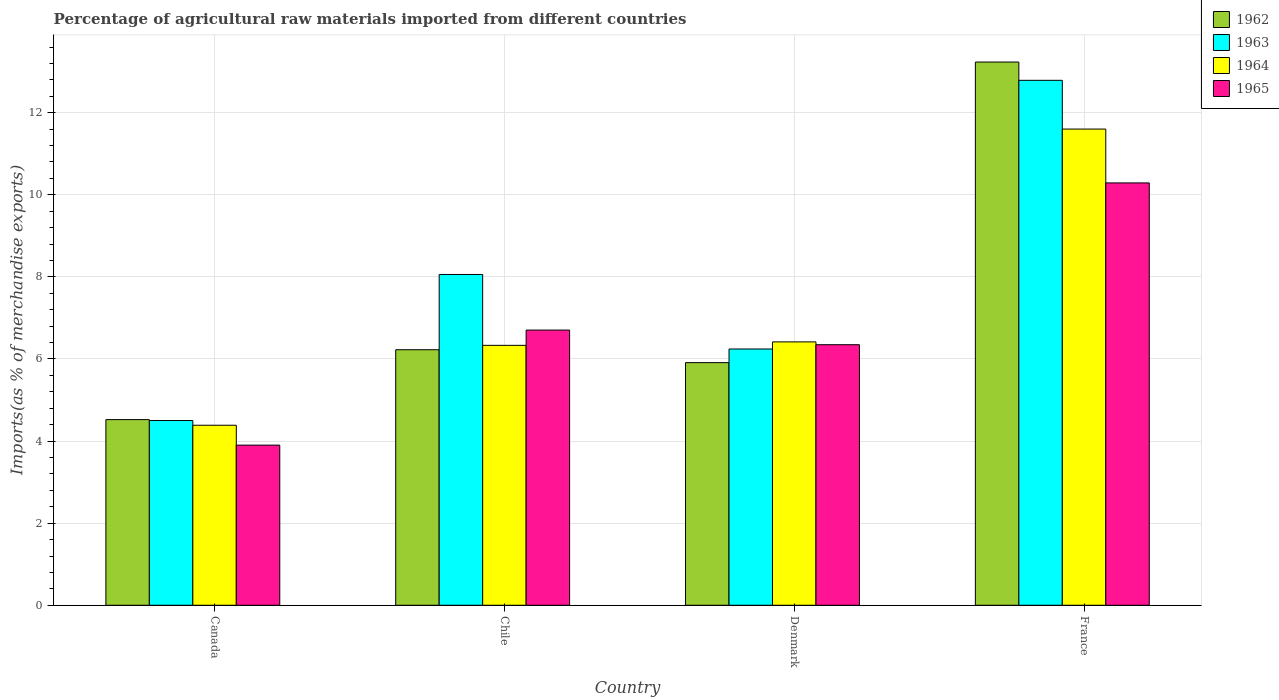How many different coloured bars are there?
Give a very brief answer. 4. How many groups of bars are there?
Your answer should be very brief. 4. Are the number of bars per tick equal to the number of legend labels?
Offer a very short reply. Yes. Are the number of bars on each tick of the X-axis equal?
Ensure brevity in your answer.  Yes. How many bars are there on the 4th tick from the right?
Offer a very short reply. 4. In how many cases, is the number of bars for a given country not equal to the number of legend labels?
Provide a short and direct response. 0. What is the percentage of imports to different countries in 1965 in Canada?
Your response must be concise. 3.9. Across all countries, what is the maximum percentage of imports to different countries in 1963?
Offer a very short reply. 12.79. Across all countries, what is the minimum percentage of imports to different countries in 1964?
Provide a succinct answer. 4.39. In which country was the percentage of imports to different countries in 1964 minimum?
Offer a terse response. Canada. What is the total percentage of imports to different countries in 1962 in the graph?
Keep it short and to the point. 29.9. What is the difference between the percentage of imports to different countries in 1965 in Canada and that in Chile?
Provide a succinct answer. -2.8. What is the difference between the percentage of imports to different countries in 1962 in Chile and the percentage of imports to different countries in 1963 in Denmark?
Provide a succinct answer. -0.02. What is the average percentage of imports to different countries in 1964 per country?
Your answer should be compact. 7.18. What is the difference between the percentage of imports to different countries of/in 1963 and percentage of imports to different countries of/in 1965 in Canada?
Provide a succinct answer. 0.6. What is the ratio of the percentage of imports to different countries in 1965 in Canada to that in Chile?
Give a very brief answer. 0.58. What is the difference between the highest and the second highest percentage of imports to different countries in 1962?
Keep it short and to the point. -7.32. What is the difference between the highest and the lowest percentage of imports to different countries in 1965?
Offer a very short reply. 6.39. Is the sum of the percentage of imports to different countries in 1964 in Denmark and France greater than the maximum percentage of imports to different countries in 1965 across all countries?
Make the answer very short. Yes. What does the 4th bar from the left in Canada represents?
Keep it short and to the point. 1965. What does the 1st bar from the right in Canada represents?
Offer a terse response. 1965. Are all the bars in the graph horizontal?
Your answer should be very brief. No. How many countries are there in the graph?
Provide a succinct answer. 4. Where does the legend appear in the graph?
Ensure brevity in your answer.  Top right. How many legend labels are there?
Provide a short and direct response. 4. What is the title of the graph?
Provide a succinct answer. Percentage of agricultural raw materials imported from different countries. What is the label or title of the Y-axis?
Offer a very short reply. Imports(as % of merchandise exports). What is the Imports(as % of merchandise exports) of 1962 in Canada?
Your response must be concise. 4.52. What is the Imports(as % of merchandise exports) of 1963 in Canada?
Provide a short and direct response. 4.5. What is the Imports(as % of merchandise exports) in 1964 in Canada?
Keep it short and to the point. 4.39. What is the Imports(as % of merchandise exports) in 1965 in Canada?
Keep it short and to the point. 3.9. What is the Imports(as % of merchandise exports) in 1962 in Chile?
Give a very brief answer. 6.23. What is the Imports(as % of merchandise exports) in 1963 in Chile?
Your answer should be compact. 8.06. What is the Imports(as % of merchandise exports) in 1964 in Chile?
Your answer should be very brief. 6.33. What is the Imports(as % of merchandise exports) of 1965 in Chile?
Provide a succinct answer. 6.7. What is the Imports(as % of merchandise exports) in 1962 in Denmark?
Provide a succinct answer. 5.91. What is the Imports(as % of merchandise exports) in 1963 in Denmark?
Provide a succinct answer. 6.24. What is the Imports(as % of merchandise exports) of 1964 in Denmark?
Offer a terse response. 6.42. What is the Imports(as % of merchandise exports) in 1965 in Denmark?
Ensure brevity in your answer.  6.35. What is the Imports(as % of merchandise exports) of 1962 in France?
Provide a succinct answer. 13.24. What is the Imports(as % of merchandise exports) of 1963 in France?
Offer a very short reply. 12.79. What is the Imports(as % of merchandise exports) in 1964 in France?
Keep it short and to the point. 11.6. What is the Imports(as % of merchandise exports) of 1965 in France?
Provide a succinct answer. 10.29. Across all countries, what is the maximum Imports(as % of merchandise exports) in 1962?
Offer a terse response. 13.24. Across all countries, what is the maximum Imports(as % of merchandise exports) of 1963?
Give a very brief answer. 12.79. Across all countries, what is the maximum Imports(as % of merchandise exports) in 1964?
Offer a very short reply. 11.6. Across all countries, what is the maximum Imports(as % of merchandise exports) in 1965?
Give a very brief answer. 10.29. Across all countries, what is the minimum Imports(as % of merchandise exports) of 1962?
Your answer should be compact. 4.52. Across all countries, what is the minimum Imports(as % of merchandise exports) in 1963?
Offer a very short reply. 4.5. Across all countries, what is the minimum Imports(as % of merchandise exports) in 1964?
Your response must be concise. 4.39. Across all countries, what is the minimum Imports(as % of merchandise exports) of 1965?
Your response must be concise. 3.9. What is the total Imports(as % of merchandise exports) in 1962 in the graph?
Offer a terse response. 29.9. What is the total Imports(as % of merchandise exports) in 1963 in the graph?
Give a very brief answer. 31.59. What is the total Imports(as % of merchandise exports) in 1964 in the graph?
Your answer should be compact. 28.74. What is the total Imports(as % of merchandise exports) of 1965 in the graph?
Ensure brevity in your answer.  27.24. What is the difference between the Imports(as % of merchandise exports) in 1962 in Canada and that in Chile?
Give a very brief answer. -1.7. What is the difference between the Imports(as % of merchandise exports) in 1963 in Canada and that in Chile?
Offer a very short reply. -3.56. What is the difference between the Imports(as % of merchandise exports) of 1964 in Canada and that in Chile?
Make the answer very short. -1.95. What is the difference between the Imports(as % of merchandise exports) in 1965 in Canada and that in Chile?
Your answer should be very brief. -2.8. What is the difference between the Imports(as % of merchandise exports) of 1962 in Canada and that in Denmark?
Your answer should be compact. -1.39. What is the difference between the Imports(as % of merchandise exports) of 1963 in Canada and that in Denmark?
Give a very brief answer. -1.74. What is the difference between the Imports(as % of merchandise exports) in 1964 in Canada and that in Denmark?
Provide a succinct answer. -2.03. What is the difference between the Imports(as % of merchandise exports) of 1965 in Canada and that in Denmark?
Make the answer very short. -2.45. What is the difference between the Imports(as % of merchandise exports) of 1962 in Canada and that in France?
Give a very brief answer. -8.71. What is the difference between the Imports(as % of merchandise exports) in 1963 in Canada and that in France?
Your answer should be very brief. -8.29. What is the difference between the Imports(as % of merchandise exports) in 1964 in Canada and that in France?
Keep it short and to the point. -7.22. What is the difference between the Imports(as % of merchandise exports) of 1965 in Canada and that in France?
Your answer should be very brief. -6.39. What is the difference between the Imports(as % of merchandise exports) in 1962 in Chile and that in Denmark?
Offer a very short reply. 0.31. What is the difference between the Imports(as % of merchandise exports) in 1963 in Chile and that in Denmark?
Offer a terse response. 1.82. What is the difference between the Imports(as % of merchandise exports) of 1964 in Chile and that in Denmark?
Your answer should be very brief. -0.08. What is the difference between the Imports(as % of merchandise exports) of 1965 in Chile and that in Denmark?
Your answer should be very brief. 0.36. What is the difference between the Imports(as % of merchandise exports) of 1962 in Chile and that in France?
Provide a succinct answer. -7.01. What is the difference between the Imports(as % of merchandise exports) of 1963 in Chile and that in France?
Make the answer very short. -4.73. What is the difference between the Imports(as % of merchandise exports) in 1964 in Chile and that in France?
Ensure brevity in your answer.  -5.27. What is the difference between the Imports(as % of merchandise exports) of 1965 in Chile and that in France?
Ensure brevity in your answer.  -3.59. What is the difference between the Imports(as % of merchandise exports) in 1962 in Denmark and that in France?
Make the answer very short. -7.32. What is the difference between the Imports(as % of merchandise exports) in 1963 in Denmark and that in France?
Make the answer very short. -6.55. What is the difference between the Imports(as % of merchandise exports) in 1964 in Denmark and that in France?
Your answer should be very brief. -5.19. What is the difference between the Imports(as % of merchandise exports) in 1965 in Denmark and that in France?
Give a very brief answer. -3.94. What is the difference between the Imports(as % of merchandise exports) in 1962 in Canada and the Imports(as % of merchandise exports) in 1963 in Chile?
Offer a very short reply. -3.54. What is the difference between the Imports(as % of merchandise exports) in 1962 in Canada and the Imports(as % of merchandise exports) in 1964 in Chile?
Provide a short and direct response. -1.81. What is the difference between the Imports(as % of merchandise exports) of 1962 in Canada and the Imports(as % of merchandise exports) of 1965 in Chile?
Give a very brief answer. -2.18. What is the difference between the Imports(as % of merchandise exports) in 1963 in Canada and the Imports(as % of merchandise exports) in 1964 in Chile?
Provide a short and direct response. -1.83. What is the difference between the Imports(as % of merchandise exports) of 1963 in Canada and the Imports(as % of merchandise exports) of 1965 in Chile?
Give a very brief answer. -2.2. What is the difference between the Imports(as % of merchandise exports) in 1964 in Canada and the Imports(as % of merchandise exports) in 1965 in Chile?
Provide a succinct answer. -2.32. What is the difference between the Imports(as % of merchandise exports) in 1962 in Canada and the Imports(as % of merchandise exports) in 1963 in Denmark?
Provide a succinct answer. -1.72. What is the difference between the Imports(as % of merchandise exports) of 1962 in Canada and the Imports(as % of merchandise exports) of 1964 in Denmark?
Provide a succinct answer. -1.89. What is the difference between the Imports(as % of merchandise exports) of 1962 in Canada and the Imports(as % of merchandise exports) of 1965 in Denmark?
Keep it short and to the point. -1.83. What is the difference between the Imports(as % of merchandise exports) in 1963 in Canada and the Imports(as % of merchandise exports) in 1964 in Denmark?
Provide a succinct answer. -1.92. What is the difference between the Imports(as % of merchandise exports) of 1963 in Canada and the Imports(as % of merchandise exports) of 1965 in Denmark?
Offer a very short reply. -1.85. What is the difference between the Imports(as % of merchandise exports) in 1964 in Canada and the Imports(as % of merchandise exports) in 1965 in Denmark?
Keep it short and to the point. -1.96. What is the difference between the Imports(as % of merchandise exports) of 1962 in Canada and the Imports(as % of merchandise exports) of 1963 in France?
Offer a terse response. -8.27. What is the difference between the Imports(as % of merchandise exports) of 1962 in Canada and the Imports(as % of merchandise exports) of 1964 in France?
Your answer should be compact. -7.08. What is the difference between the Imports(as % of merchandise exports) of 1962 in Canada and the Imports(as % of merchandise exports) of 1965 in France?
Provide a succinct answer. -5.77. What is the difference between the Imports(as % of merchandise exports) of 1963 in Canada and the Imports(as % of merchandise exports) of 1964 in France?
Offer a terse response. -7.1. What is the difference between the Imports(as % of merchandise exports) in 1963 in Canada and the Imports(as % of merchandise exports) in 1965 in France?
Provide a succinct answer. -5.79. What is the difference between the Imports(as % of merchandise exports) of 1964 in Canada and the Imports(as % of merchandise exports) of 1965 in France?
Your answer should be compact. -5.9. What is the difference between the Imports(as % of merchandise exports) in 1962 in Chile and the Imports(as % of merchandise exports) in 1963 in Denmark?
Keep it short and to the point. -0.02. What is the difference between the Imports(as % of merchandise exports) in 1962 in Chile and the Imports(as % of merchandise exports) in 1964 in Denmark?
Keep it short and to the point. -0.19. What is the difference between the Imports(as % of merchandise exports) in 1962 in Chile and the Imports(as % of merchandise exports) in 1965 in Denmark?
Provide a short and direct response. -0.12. What is the difference between the Imports(as % of merchandise exports) in 1963 in Chile and the Imports(as % of merchandise exports) in 1964 in Denmark?
Make the answer very short. 1.64. What is the difference between the Imports(as % of merchandise exports) in 1963 in Chile and the Imports(as % of merchandise exports) in 1965 in Denmark?
Keep it short and to the point. 1.71. What is the difference between the Imports(as % of merchandise exports) in 1964 in Chile and the Imports(as % of merchandise exports) in 1965 in Denmark?
Keep it short and to the point. -0.02. What is the difference between the Imports(as % of merchandise exports) of 1962 in Chile and the Imports(as % of merchandise exports) of 1963 in France?
Your answer should be compact. -6.56. What is the difference between the Imports(as % of merchandise exports) in 1962 in Chile and the Imports(as % of merchandise exports) in 1964 in France?
Provide a short and direct response. -5.38. What is the difference between the Imports(as % of merchandise exports) of 1962 in Chile and the Imports(as % of merchandise exports) of 1965 in France?
Provide a succinct answer. -4.06. What is the difference between the Imports(as % of merchandise exports) in 1963 in Chile and the Imports(as % of merchandise exports) in 1964 in France?
Provide a short and direct response. -3.54. What is the difference between the Imports(as % of merchandise exports) in 1963 in Chile and the Imports(as % of merchandise exports) in 1965 in France?
Offer a very short reply. -2.23. What is the difference between the Imports(as % of merchandise exports) in 1964 in Chile and the Imports(as % of merchandise exports) in 1965 in France?
Make the answer very short. -3.96. What is the difference between the Imports(as % of merchandise exports) in 1962 in Denmark and the Imports(as % of merchandise exports) in 1963 in France?
Offer a terse response. -6.88. What is the difference between the Imports(as % of merchandise exports) of 1962 in Denmark and the Imports(as % of merchandise exports) of 1964 in France?
Provide a short and direct response. -5.69. What is the difference between the Imports(as % of merchandise exports) of 1962 in Denmark and the Imports(as % of merchandise exports) of 1965 in France?
Offer a terse response. -4.38. What is the difference between the Imports(as % of merchandise exports) in 1963 in Denmark and the Imports(as % of merchandise exports) in 1964 in France?
Your answer should be very brief. -5.36. What is the difference between the Imports(as % of merchandise exports) in 1963 in Denmark and the Imports(as % of merchandise exports) in 1965 in France?
Provide a succinct answer. -4.05. What is the difference between the Imports(as % of merchandise exports) of 1964 in Denmark and the Imports(as % of merchandise exports) of 1965 in France?
Keep it short and to the point. -3.87. What is the average Imports(as % of merchandise exports) of 1962 per country?
Keep it short and to the point. 7.47. What is the average Imports(as % of merchandise exports) of 1963 per country?
Make the answer very short. 7.9. What is the average Imports(as % of merchandise exports) of 1964 per country?
Your answer should be very brief. 7.18. What is the average Imports(as % of merchandise exports) in 1965 per country?
Ensure brevity in your answer.  6.81. What is the difference between the Imports(as % of merchandise exports) of 1962 and Imports(as % of merchandise exports) of 1963 in Canada?
Ensure brevity in your answer.  0.02. What is the difference between the Imports(as % of merchandise exports) of 1962 and Imports(as % of merchandise exports) of 1964 in Canada?
Keep it short and to the point. 0.14. What is the difference between the Imports(as % of merchandise exports) in 1962 and Imports(as % of merchandise exports) in 1965 in Canada?
Keep it short and to the point. 0.62. What is the difference between the Imports(as % of merchandise exports) in 1963 and Imports(as % of merchandise exports) in 1964 in Canada?
Your answer should be very brief. 0.12. What is the difference between the Imports(as % of merchandise exports) of 1963 and Imports(as % of merchandise exports) of 1965 in Canada?
Make the answer very short. 0.6. What is the difference between the Imports(as % of merchandise exports) in 1964 and Imports(as % of merchandise exports) in 1965 in Canada?
Give a very brief answer. 0.48. What is the difference between the Imports(as % of merchandise exports) of 1962 and Imports(as % of merchandise exports) of 1963 in Chile?
Offer a very short reply. -1.83. What is the difference between the Imports(as % of merchandise exports) of 1962 and Imports(as % of merchandise exports) of 1964 in Chile?
Make the answer very short. -0.11. What is the difference between the Imports(as % of merchandise exports) of 1962 and Imports(as % of merchandise exports) of 1965 in Chile?
Offer a terse response. -0.48. What is the difference between the Imports(as % of merchandise exports) of 1963 and Imports(as % of merchandise exports) of 1964 in Chile?
Provide a succinct answer. 1.73. What is the difference between the Imports(as % of merchandise exports) in 1963 and Imports(as % of merchandise exports) in 1965 in Chile?
Your answer should be very brief. 1.35. What is the difference between the Imports(as % of merchandise exports) in 1964 and Imports(as % of merchandise exports) in 1965 in Chile?
Your answer should be very brief. -0.37. What is the difference between the Imports(as % of merchandise exports) in 1962 and Imports(as % of merchandise exports) in 1963 in Denmark?
Give a very brief answer. -0.33. What is the difference between the Imports(as % of merchandise exports) of 1962 and Imports(as % of merchandise exports) of 1964 in Denmark?
Provide a short and direct response. -0.51. What is the difference between the Imports(as % of merchandise exports) of 1962 and Imports(as % of merchandise exports) of 1965 in Denmark?
Ensure brevity in your answer.  -0.44. What is the difference between the Imports(as % of merchandise exports) in 1963 and Imports(as % of merchandise exports) in 1964 in Denmark?
Offer a terse response. -0.17. What is the difference between the Imports(as % of merchandise exports) in 1963 and Imports(as % of merchandise exports) in 1965 in Denmark?
Your answer should be very brief. -0.1. What is the difference between the Imports(as % of merchandise exports) in 1964 and Imports(as % of merchandise exports) in 1965 in Denmark?
Offer a terse response. 0.07. What is the difference between the Imports(as % of merchandise exports) of 1962 and Imports(as % of merchandise exports) of 1963 in France?
Ensure brevity in your answer.  0.45. What is the difference between the Imports(as % of merchandise exports) in 1962 and Imports(as % of merchandise exports) in 1964 in France?
Ensure brevity in your answer.  1.63. What is the difference between the Imports(as % of merchandise exports) of 1962 and Imports(as % of merchandise exports) of 1965 in France?
Your response must be concise. 2.95. What is the difference between the Imports(as % of merchandise exports) in 1963 and Imports(as % of merchandise exports) in 1964 in France?
Provide a succinct answer. 1.19. What is the difference between the Imports(as % of merchandise exports) of 1963 and Imports(as % of merchandise exports) of 1965 in France?
Your answer should be compact. 2.5. What is the difference between the Imports(as % of merchandise exports) of 1964 and Imports(as % of merchandise exports) of 1965 in France?
Provide a short and direct response. 1.31. What is the ratio of the Imports(as % of merchandise exports) in 1962 in Canada to that in Chile?
Your response must be concise. 0.73. What is the ratio of the Imports(as % of merchandise exports) of 1963 in Canada to that in Chile?
Provide a short and direct response. 0.56. What is the ratio of the Imports(as % of merchandise exports) in 1964 in Canada to that in Chile?
Give a very brief answer. 0.69. What is the ratio of the Imports(as % of merchandise exports) of 1965 in Canada to that in Chile?
Provide a short and direct response. 0.58. What is the ratio of the Imports(as % of merchandise exports) in 1962 in Canada to that in Denmark?
Your answer should be compact. 0.77. What is the ratio of the Imports(as % of merchandise exports) in 1963 in Canada to that in Denmark?
Ensure brevity in your answer.  0.72. What is the ratio of the Imports(as % of merchandise exports) in 1964 in Canada to that in Denmark?
Your answer should be very brief. 0.68. What is the ratio of the Imports(as % of merchandise exports) in 1965 in Canada to that in Denmark?
Keep it short and to the point. 0.61. What is the ratio of the Imports(as % of merchandise exports) in 1962 in Canada to that in France?
Offer a terse response. 0.34. What is the ratio of the Imports(as % of merchandise exports) in 1963 in Canada to that in France?
Offer a very short reply. 0.35. What is the ratio of the Imports(as % of merchandise exports) in 1964 in Canada to that in France?
Your answer should be compact. 0.38. What is the ratio of the Imports(as % of merchandise exports) in 1965 in Canada to that in France?
Offer a terse response. 0.38. What is the ratio of the Imports(as % of merchandise exports) in 1962 in Chile to that in Denmark?
Your answer should be compact. 1.05. What is the ratio of the Imports(as % of merchandise exports) of 1963 in Chile to that in Denmark?
Your response must be concise. 1.29. What is the ratio of the Imports(as % of merchandise exports) in 1964 in Chile to that in Denmark?
Make the answer very short. 0.99. What is the ratio of the Imports(as % of merchandise exports) in 1965 in Chile to that in Denmark?
Ensure brevity in your answer.  1.06. What is the ratio of the Imports(as % of merchandise exports) of 1962 in Chile to that in France?
Your answer should be compact. 0.47. What is the ratio of the Imports(as % of merchandise exports) of 1963 in Chile to that in France?
Provide a succinct answer. 0.63. What is the ratio of the Imports(as % of merchandise exports) of 1964 in Chile to that in France?
Your response must be concise. 0.55. What is the ratio of the Imports(as % of merchandise exports) of 1965 in Chile to that in France?
Ensure brevity in your answer.  0.65. What is the ratio of the Imports(as % of merchandise exports) of 1962 in Denmark to that in France?
Your answer should be very brief. 0.45. What is the ratio of the Imports(as % of merchandise exports) of 1963 in Denmark to that in France?
Offer a very short reply. 0.49. What is the ratio of the Imports(as % of merchandise exports) of 1964 in Denmark to that in France?
Give a very brief answer. 0.55. What is the ratio of the Imports(as % of merchandise exports) in 1965 in Denmark to that in France?
Your answer should be compact. 0.62. What is the difference between the highest and the second highest Imports(as % of merchandise exports) in 1962?
Provide a short and direct response. 7.01. What is the difference between the highest and the second highest Imports(as % of merchandise exports) of 1963?
Your answer should be very brief. 4.73. What is the difference between the highest and the second highest Imports(as % of merchandise exports) of 1964?
Provide a short and direct response. 5.19. What is the difference between the highest and the second highest Imports(as % of merchandise exports) in 1965?
Offer a very short reply. 3.59. What is the difference between the highest and the lowest Imports(as % of merchandise exports) of 1962?
Provide a succinct answer. 8.71. What is the difference between the highest and the lowest Imports(as % of merchandise exports) in 1963?
Your answer should be very brief. 8.29. What is the difference between the highest and the lowest Imports(as % of merchandise exports) in 1964?
Offer a very short reply. 7.22. What is the difference between the highest and the lowest Imports(as % of merchandise exports) in 1965?
Ensure brevity in your answer.  6.39. 